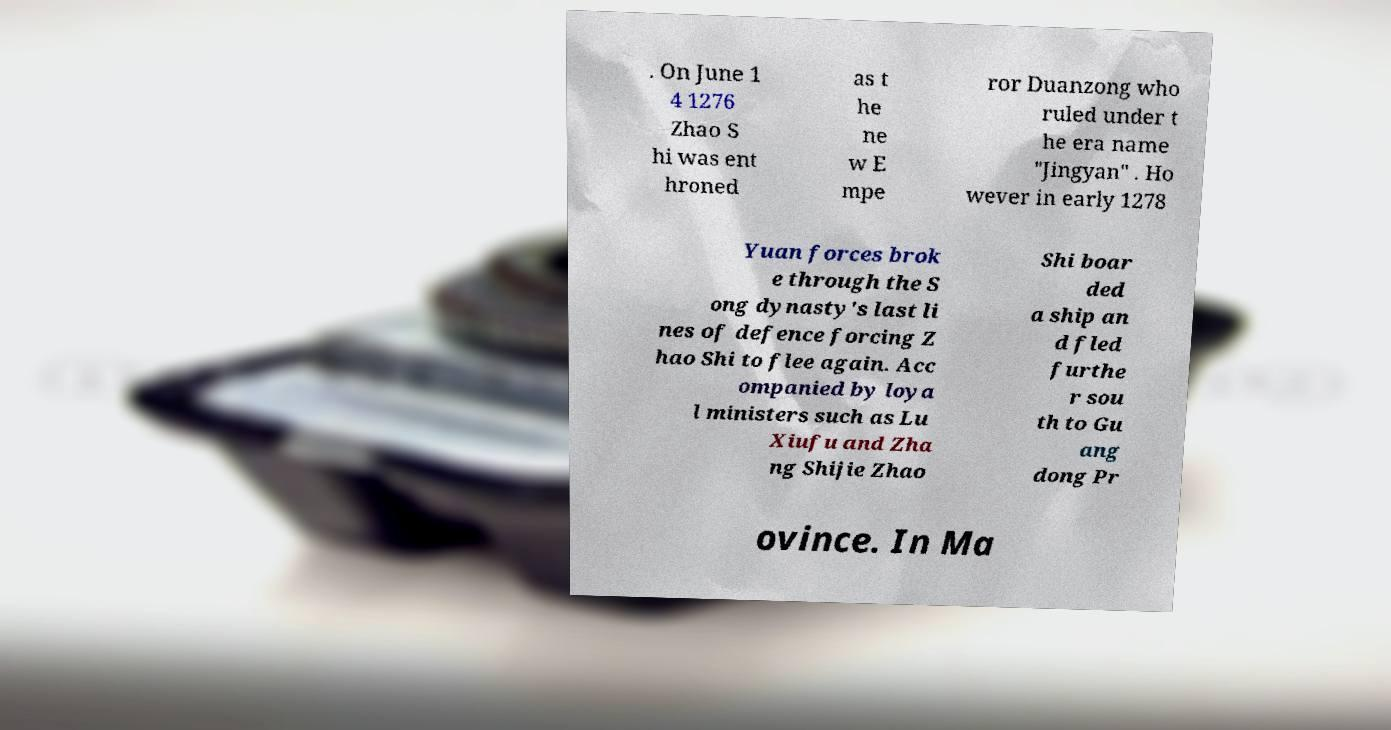Please read and relay the text visible in this image. What does it say? . On June 1 4 1276 Zhao S hi was ent hroned as t he ne w E mpe ror Duanzong who ruled under t he era name "Jingyan" . Ho wever in early 1278 Yuan forces brok e through the S ong dynasty's last li nes of defence forcing Z hao Shi to flee again. Acc ompanied by loya l ministers such as Lu Xiufu and Zha ng Shijie Zhao Shi boar ded a ship an d fled furthe r sou th to Gu ang dong Pr ovince. In Ma 